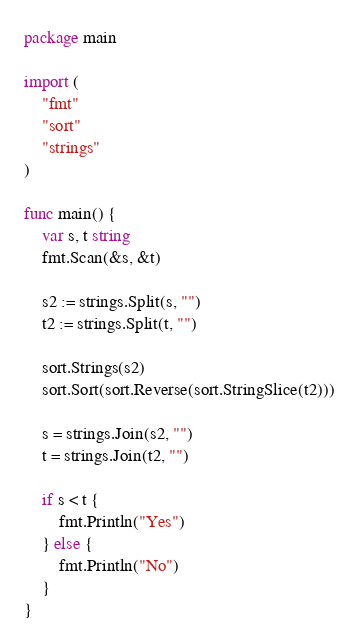<code> <loc_0><loc_0><loc_500><loc_500><_Go_>package main

import (
	"fmt"
	"sort"
	"strings"
)

func main() {
	var s, t string
	fmt.Scan(&s, &t)

	s2 := strings.Split(s, "")
	t2 := strings.Split(t, "")

	sort.Strings(s2)
	sort.Sort(sort.Reverse(sort.StringSlice(t2)))

	s = strings.Join(s2, "")
	t = strings.Join(t2, "")

	if s < t {
		fmt.Println("Yes")
	} else {
		fmt.Println("No")
	}
}
</code> 